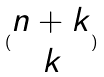<formula> <loc_0><loc_0><loc_500><loc_500>( \begin{matrix} n + k \\ k \end{matrix} )</formula> 